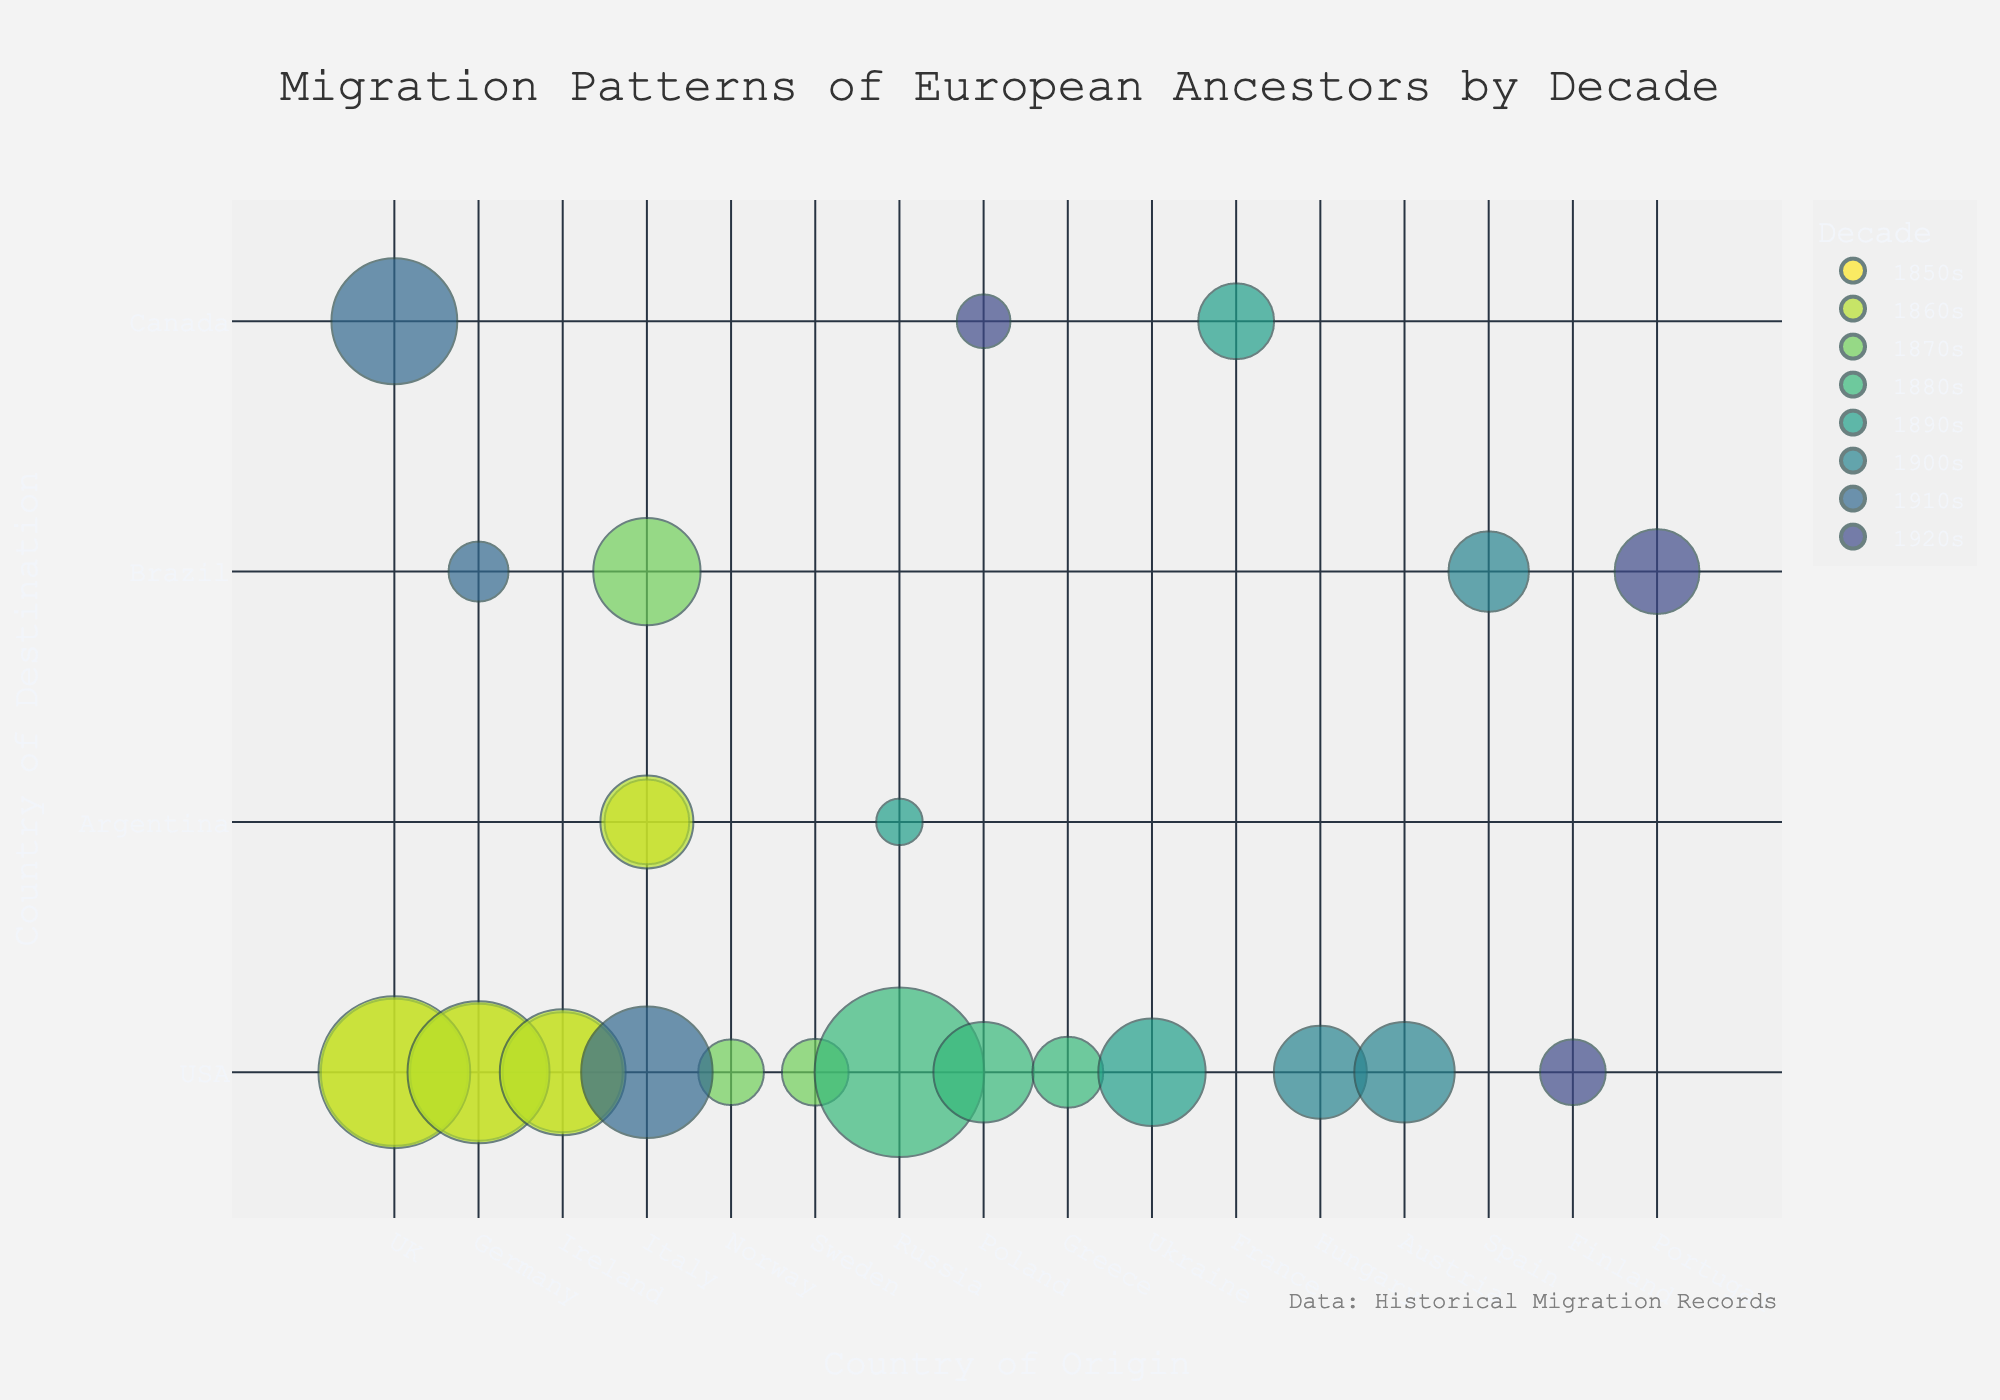Which country is the destination of the largest migration recorded in the 1880s? Refer to the bubble chart and locate the largest-sized bubble in the 1880s. It points to the USA destination from Russia, signifying the highest number of migrants.
Answer: USA What decade showed the highest migration from Italy to the USA? Locate the bubbles representing Italy to the USA across different decades. The largest bubble for this migration is in the 1910s.
Answer: 1910s Compare the number of migrants from Ireland to the USA and from Norway to the USA in the 1870s. Which is higher? Compare the sizes of the bubbles for Ireland to USA and Norway to USA in the 1870s. The bubble for Ireland to USA is larger.
Answer: Ireland to USA How many countries of origin have a migration bubble to Brazil in the 1910s? Look for all bubbles that end in Brazil in the 1910s. There is only one visible bubble, originating from Germany.
Answer: 1 Which decade experienced migration from Poland to two different countries, and what are those countries? Identify the colors representing each decade and the bubbles for Poland. The 1920s show migration to Canada and USA.
Answer: 1920s, Canada and USA What is the total number of migrants from the UK to the USA in the 1850s and 1860s combined? Sum the number of migrants from the UK to the USA in the 1850s (1,500,000) and the 1860s (1,600,000).
Answer: 3,100,000 Of the migrations to Canada, which country of origin had the highest number of migrants and in which decade? Locate bubbles ending in Canada and identify the largest one. The UK in the 1910s has the highest number of migrants.
Answer: UK, 1910s Which migration was larger, Italy to Argentina in the 1850s or Italy to Brazil in the 1870s? Compare the sizes of the bubbles representing these migrations. The bubble for Italy to Brazil in the 1870s is larger.
Answer: Italy to Brazil Identify the country of origin with the least migration to the USA in the 1900s. Review the bubbles ending in the USA for the 1900s and identify the smallest one, which comes from Hungary.
Answer: Hungary 